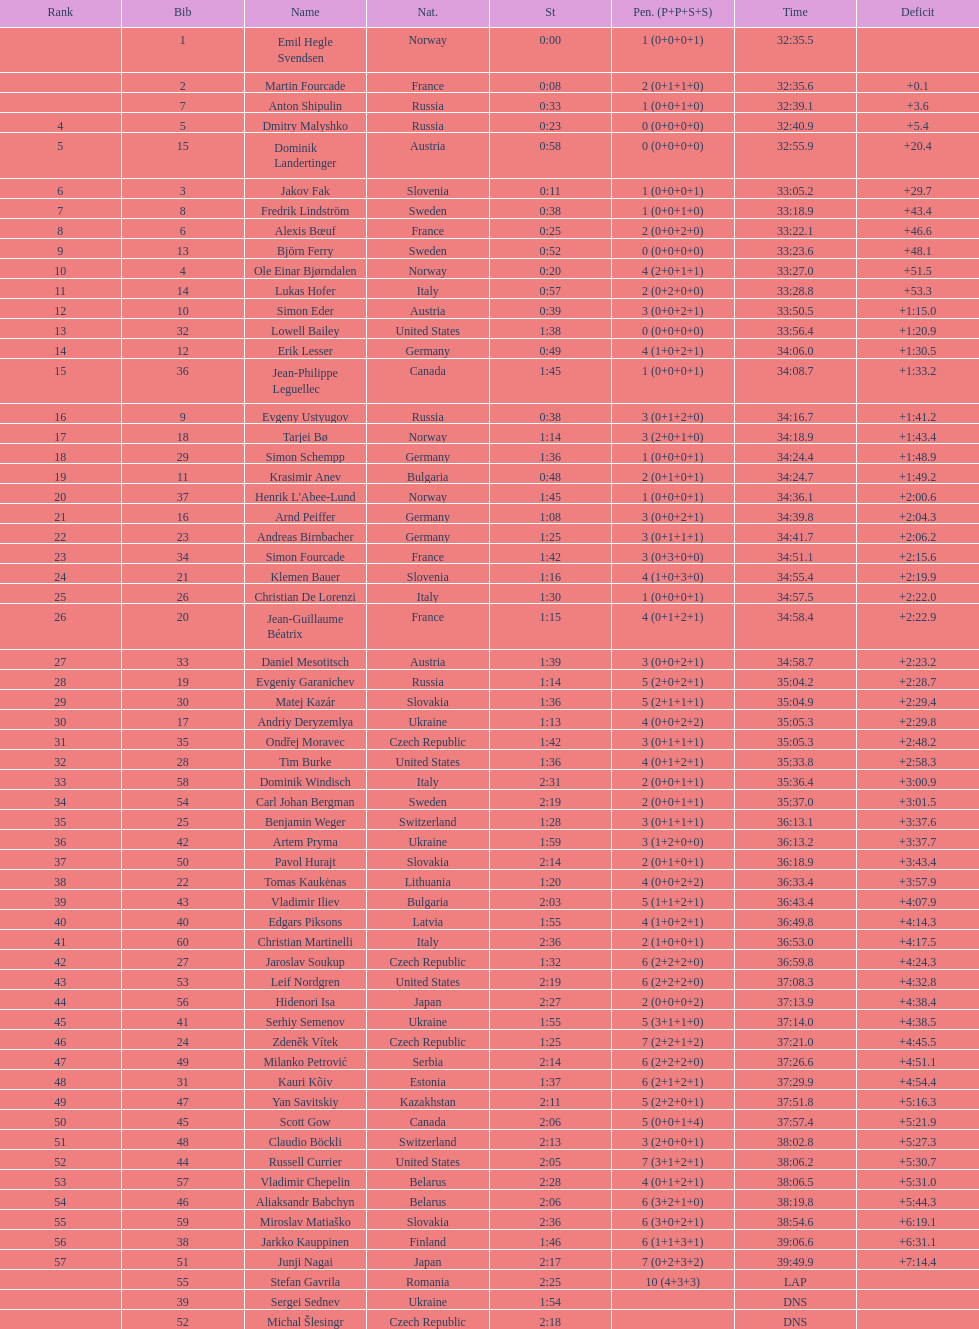What is the number of russian participants? 4. 